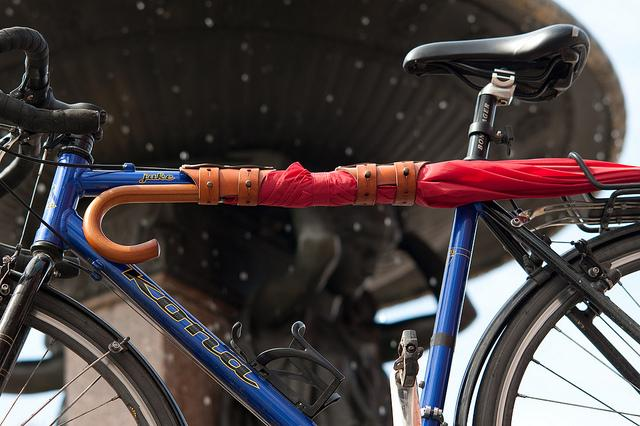What color is the umbrella strapped onto the bicycle frame's center bar?

Choices:
A) yellow
B) green
C) red
D) blue red 